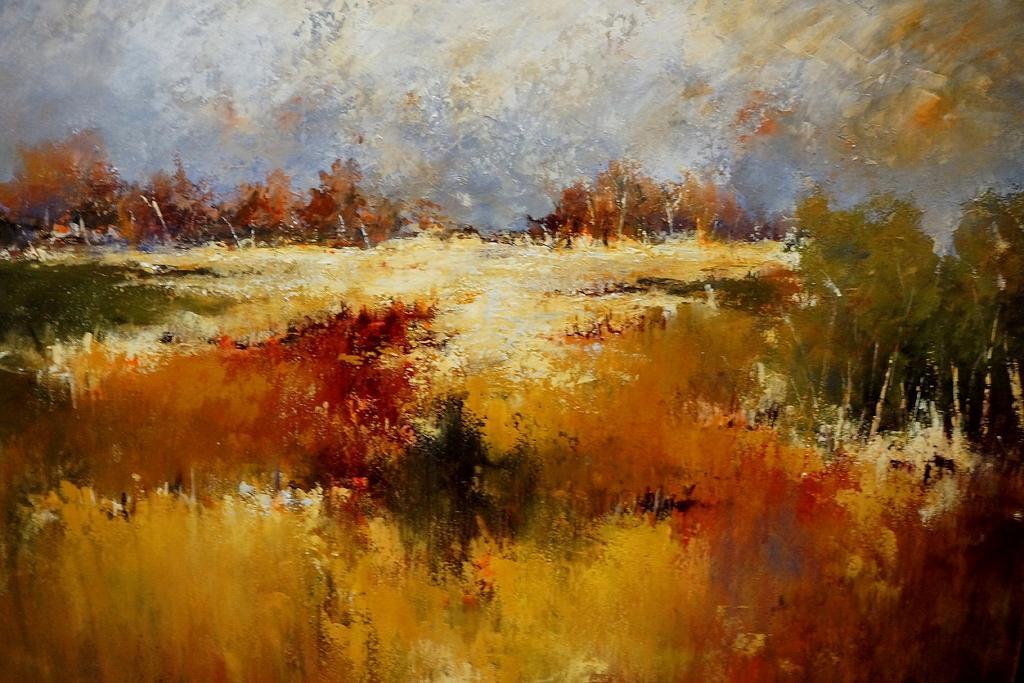Can you describe this image briefly? It is a painting picture. In the image in the center we can see trees,plants and grass. 